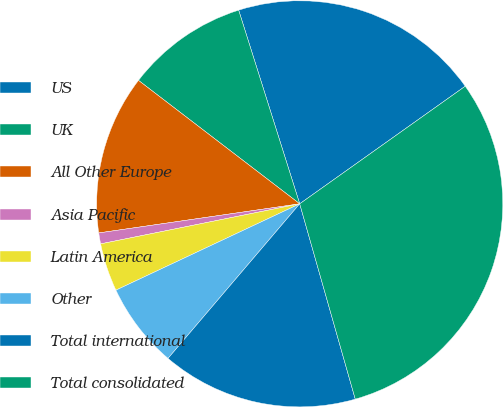Convert chart to OTSL. <chart><loc_0><loc_0><loc_500><loc_500><pie_chart><fcel>US<fcel>UK<fcel>All Other Europe<fcel>Asia Pacific<fcel>Latin America<fcel>Other<fcel>Total international<fcel>Total consolidated<nl><fcel>20.03%<fcel>9.74%<fcel>12.69%<fcel>0.87%<fcel>3.83%<fcel>6.78%<fcel>15.64%<fcel>30.42%<nl></chart> 